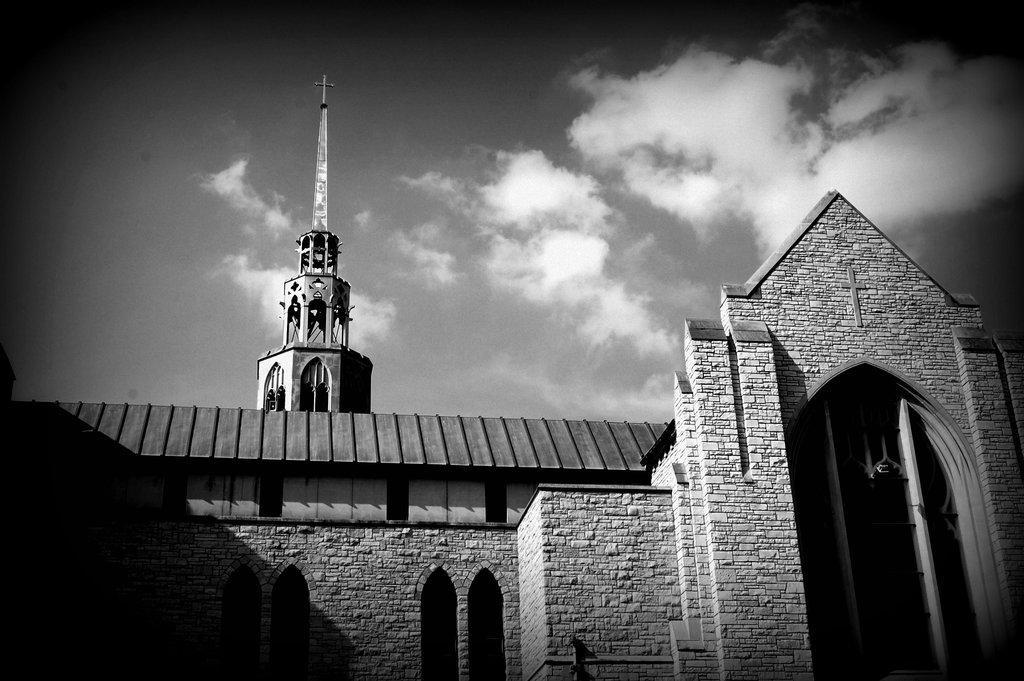Could you give a brief overview of what you see in this image? In this image I can see a building. At the top I can see the clouds in the sky. I can also see the image is in black and white color. 